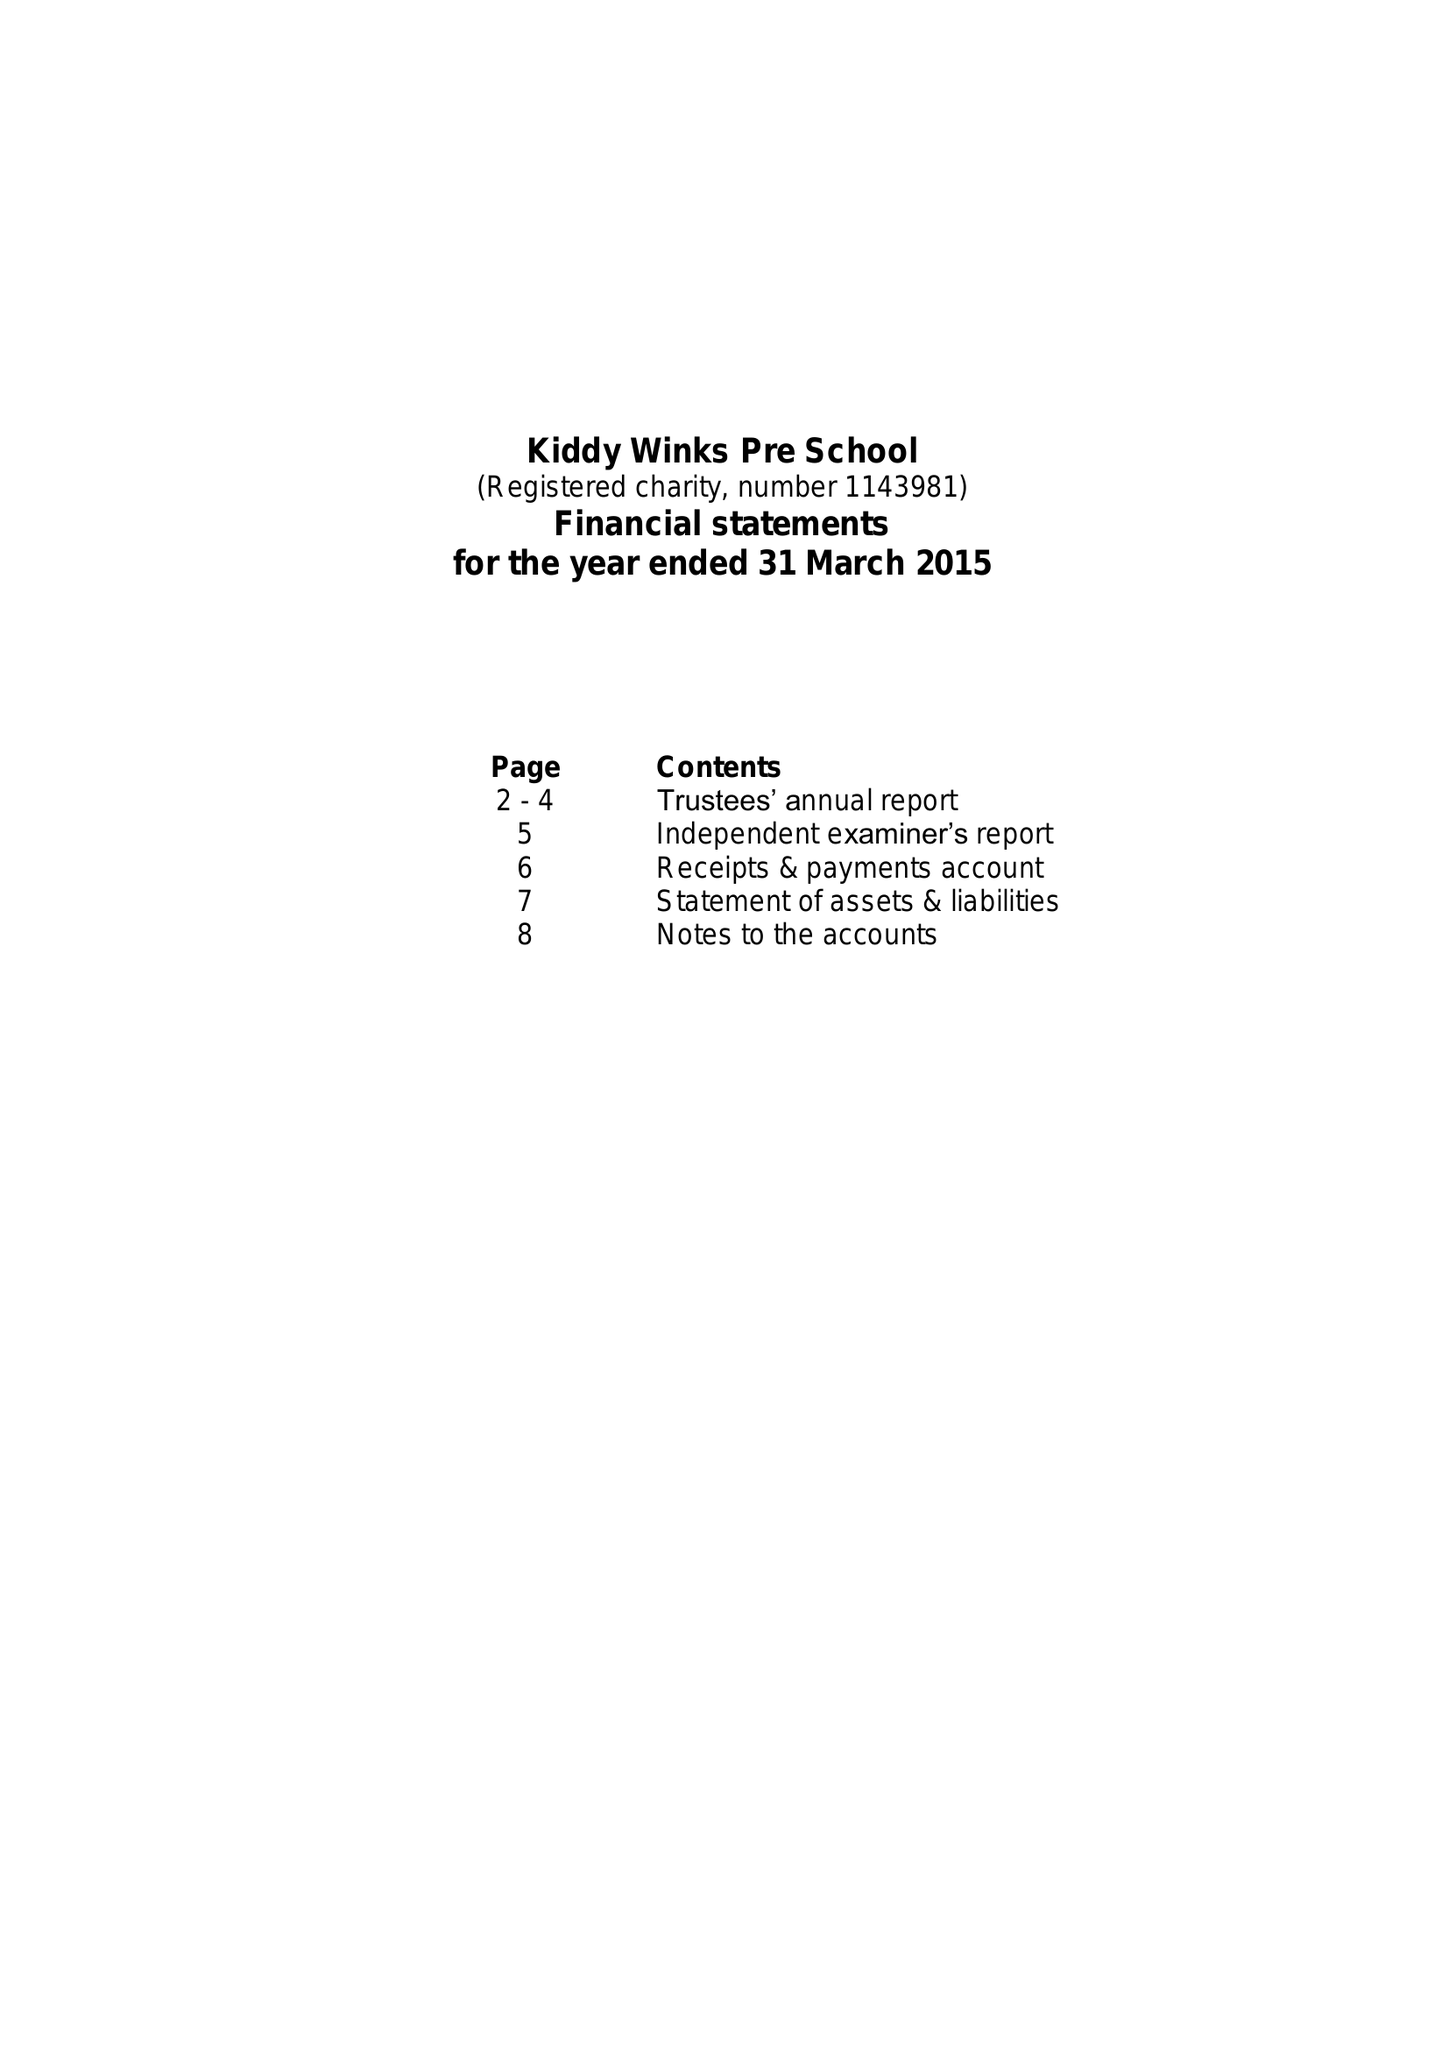What is the value for the spending_annually_in_british_pounds?
Answer the question using a single word or phrase. 99663.00 